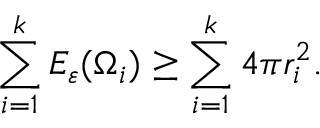Convert formula to latex. <formula><loc_0><loc_0><loc_500><loc_500>\sum _ { i = 1 } ^ { k } E _ { \varepsilon } ( \Omega _ { i } ) \geq \sum _ { i = 1 } ^ { k } 4 \pi r _ { i } ^ { 2 } .</formula> 